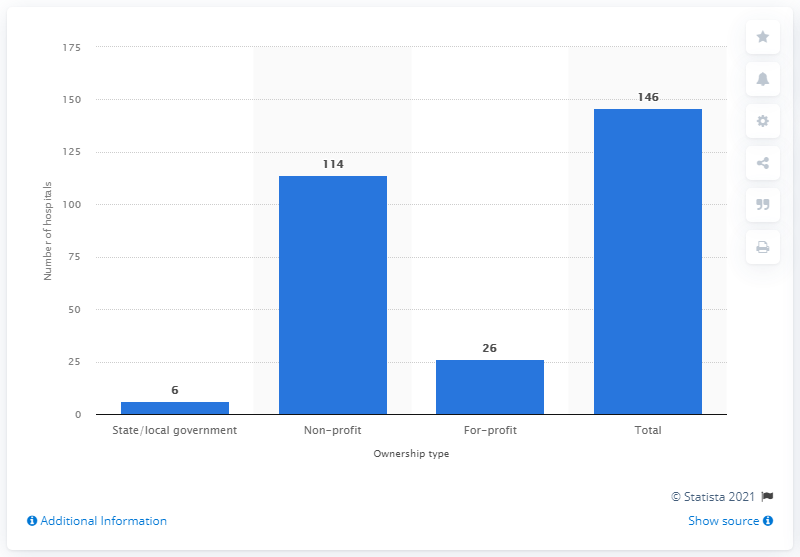Outline some significant characteristics in this image. In 2019, there were 6 hospitals in Michigan that were owned by the state or the local government. 